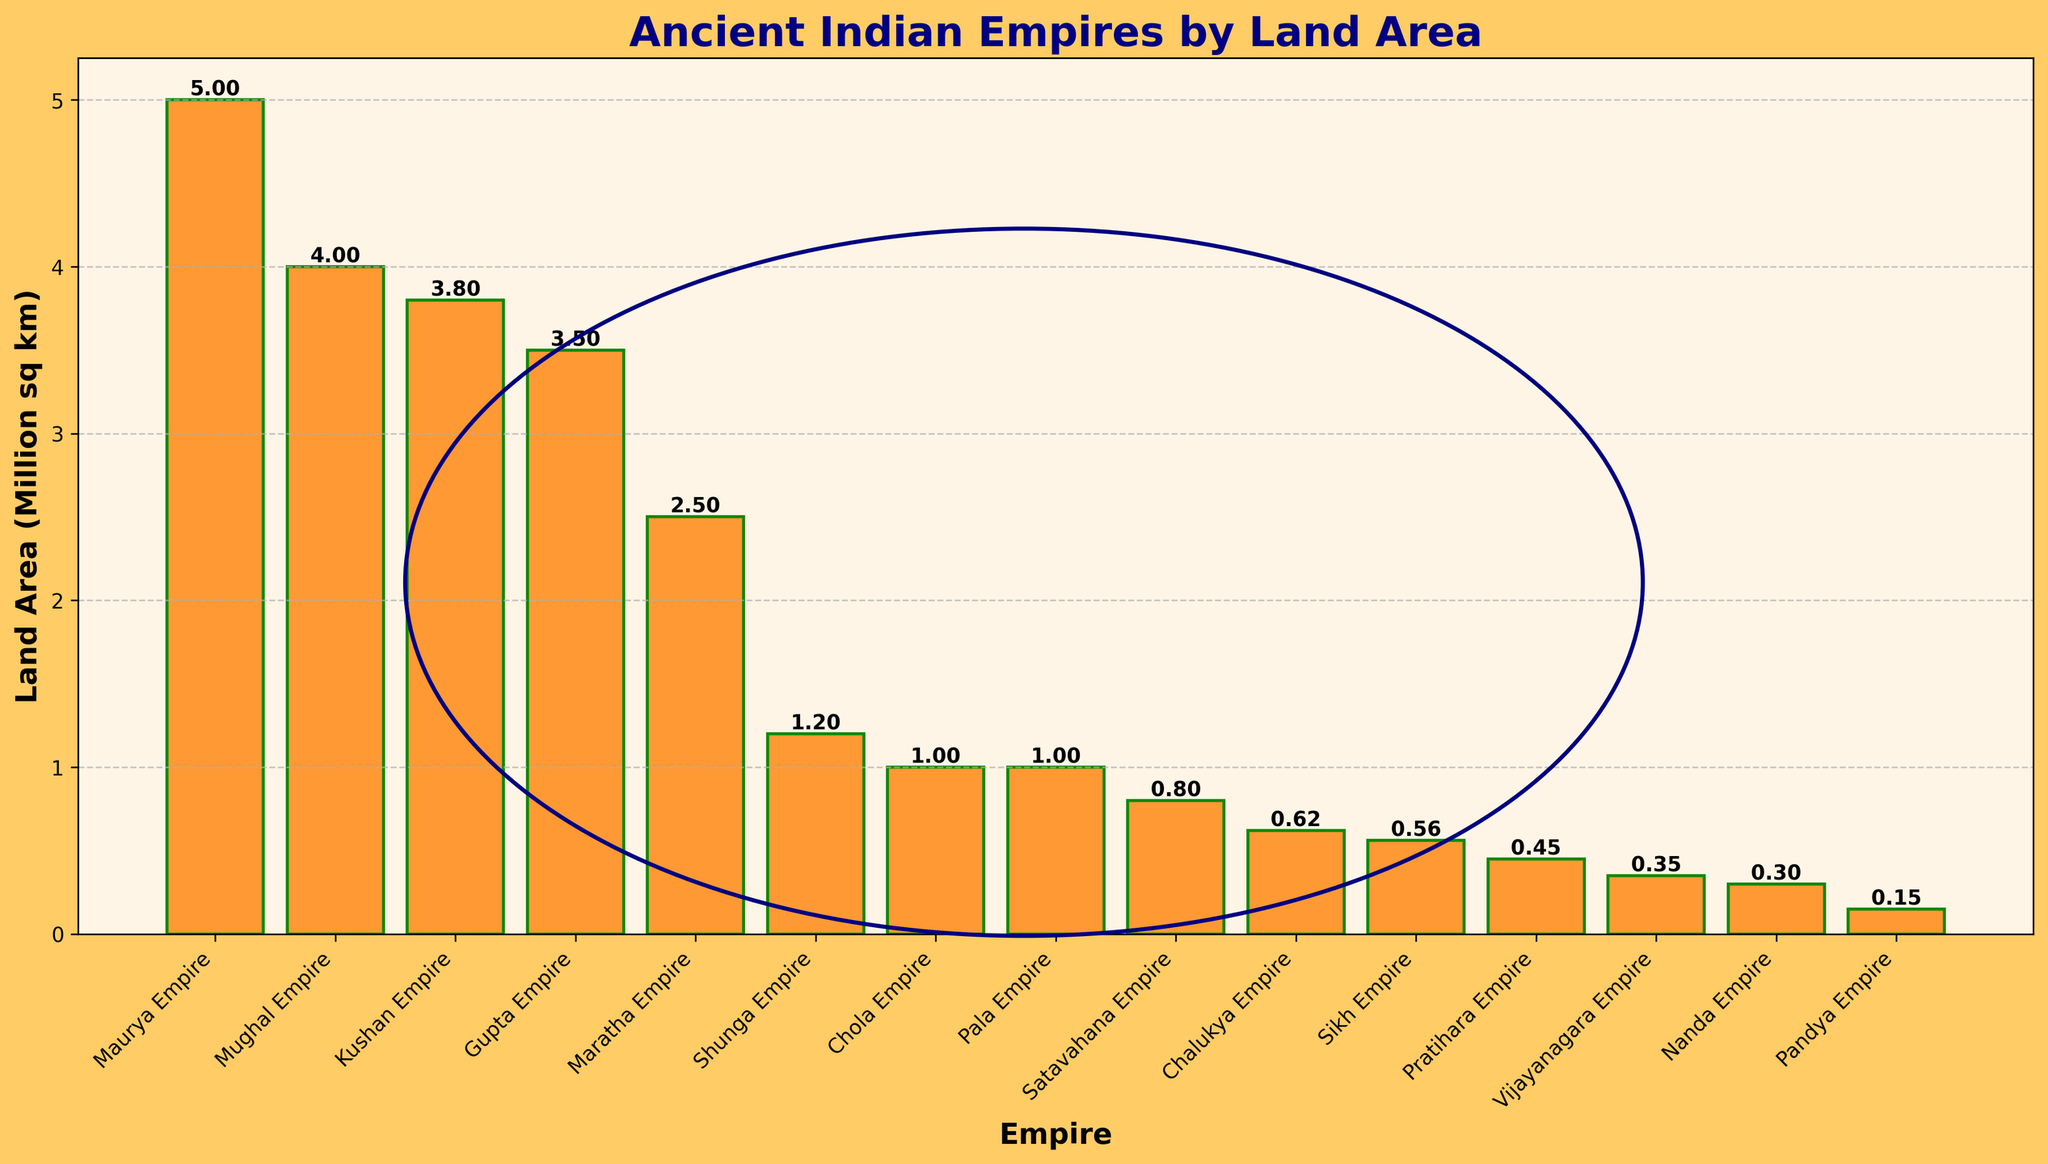Which empire had the largest land area? The figure shows the Maurya Empire has the tallest bar, indicating the largest land area among the empires.
Answer: Maurya Empire Which two empires had the same land area? Both the Chola Empire and Pala Empire have bars of equal height.
Answer: Chola Empire and Pala Empire Which empires have a land area greater than 3 million sq km but less than 4 million sq km? The Gupta Empire, Kushan Empire, and Mughal Empire have bars that fall between these heights.
Answer: Gupta Empire and Kushan Empire What is the difference in land area between the largest and the smallest empires? The largest empire is the Maurya Empire (5 million sq km) and the smallest is the Pandya Empire (0.15 million sq km). The difference is 5.00 - 0.15 = 4.85 million sq km.
Answer: 4.85 million sq km How many empires have land areas depicted as bars less than 1 million sq km? Bars for the Vijayanagara Empire, Sikh Empire, Chalukya Empire, Pratihara Empire, Nanda Empire, and Pandya Empire are all below 1 million sq km. Counting these bars gives 6 empires.
Answer: 6 What is the average land area of the three largest empires? The three largest empires are the Maurya Empire (5 million sq km), Mughal Empire (4 million sq km), and Kushan Empire (3.8 million sq km). The average is (5 + 4 + 3.8) / 3 = 4.27 million sq km.
Answer: 4.27 million sq km Which empire appears as the third in height from the largest? The third tallest bar corresponds to the Mughal Empire.
Answer: Mughal Empire Which visual element is used as a decorative background in the plot? There is a circle that looks like the Ashoka Chakra as a decorative background element.
Answer: Ashoka Chakra What is the combined land area of Gupta Empire and Satavahana Empire? The Gupta Empire has 3.5 million sq km and the Satavahana Empire has 0.8 million sq km. Their combined land area is 3.5 + 0.8 = 4.3 million sq km.
Answer: 4.3 million sq km What is the color of the bars in the bar chart? The bars in the bar chart are in a saffron-like color.
Answer: Saffron-colored 